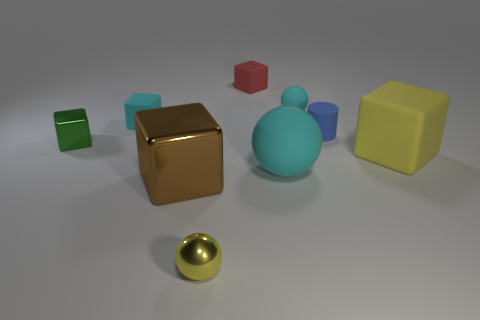There is a thing that is the same color as the tiny metallic ball; what material is it?
Give a very brief answer. Rubber. There is a cube that is on the left side of the red thing and behind the small green metal object; what is its size?
Ensure brevity in your answer.  Small. How many cylinders are large cyan things or small yellow things?
Give a very brief answer. 0. What color is the metallic sphere that is the same size as the green metallic thing?
Your response must be concise. Yellow. Is there any other thing that is the same shape as the small green thing?
Your answer should be compact. Yes. What color is the tiny metal object that is the same shape as the large yellow rubber thing?
Ensure brevity in your answer.  Green. How many objects are either cubes or small rubber cubes left of the brown thing?
Your answer should be very brief. 5. Is the number of tiny cyan things that are behind the small red rubber thing less than the number of small metallic blocks?
Your answer should be very brief. Yes. There is a rubber block in front of the cyan object that is on the left side of the big block that is left of the small matte cylinder; what is its size?
Offer a terse response. Large. There is a rubber object that is both left of the big yellow object and in front of the small shiny cube; what is its color?
Make the answer very short. Cyan. 